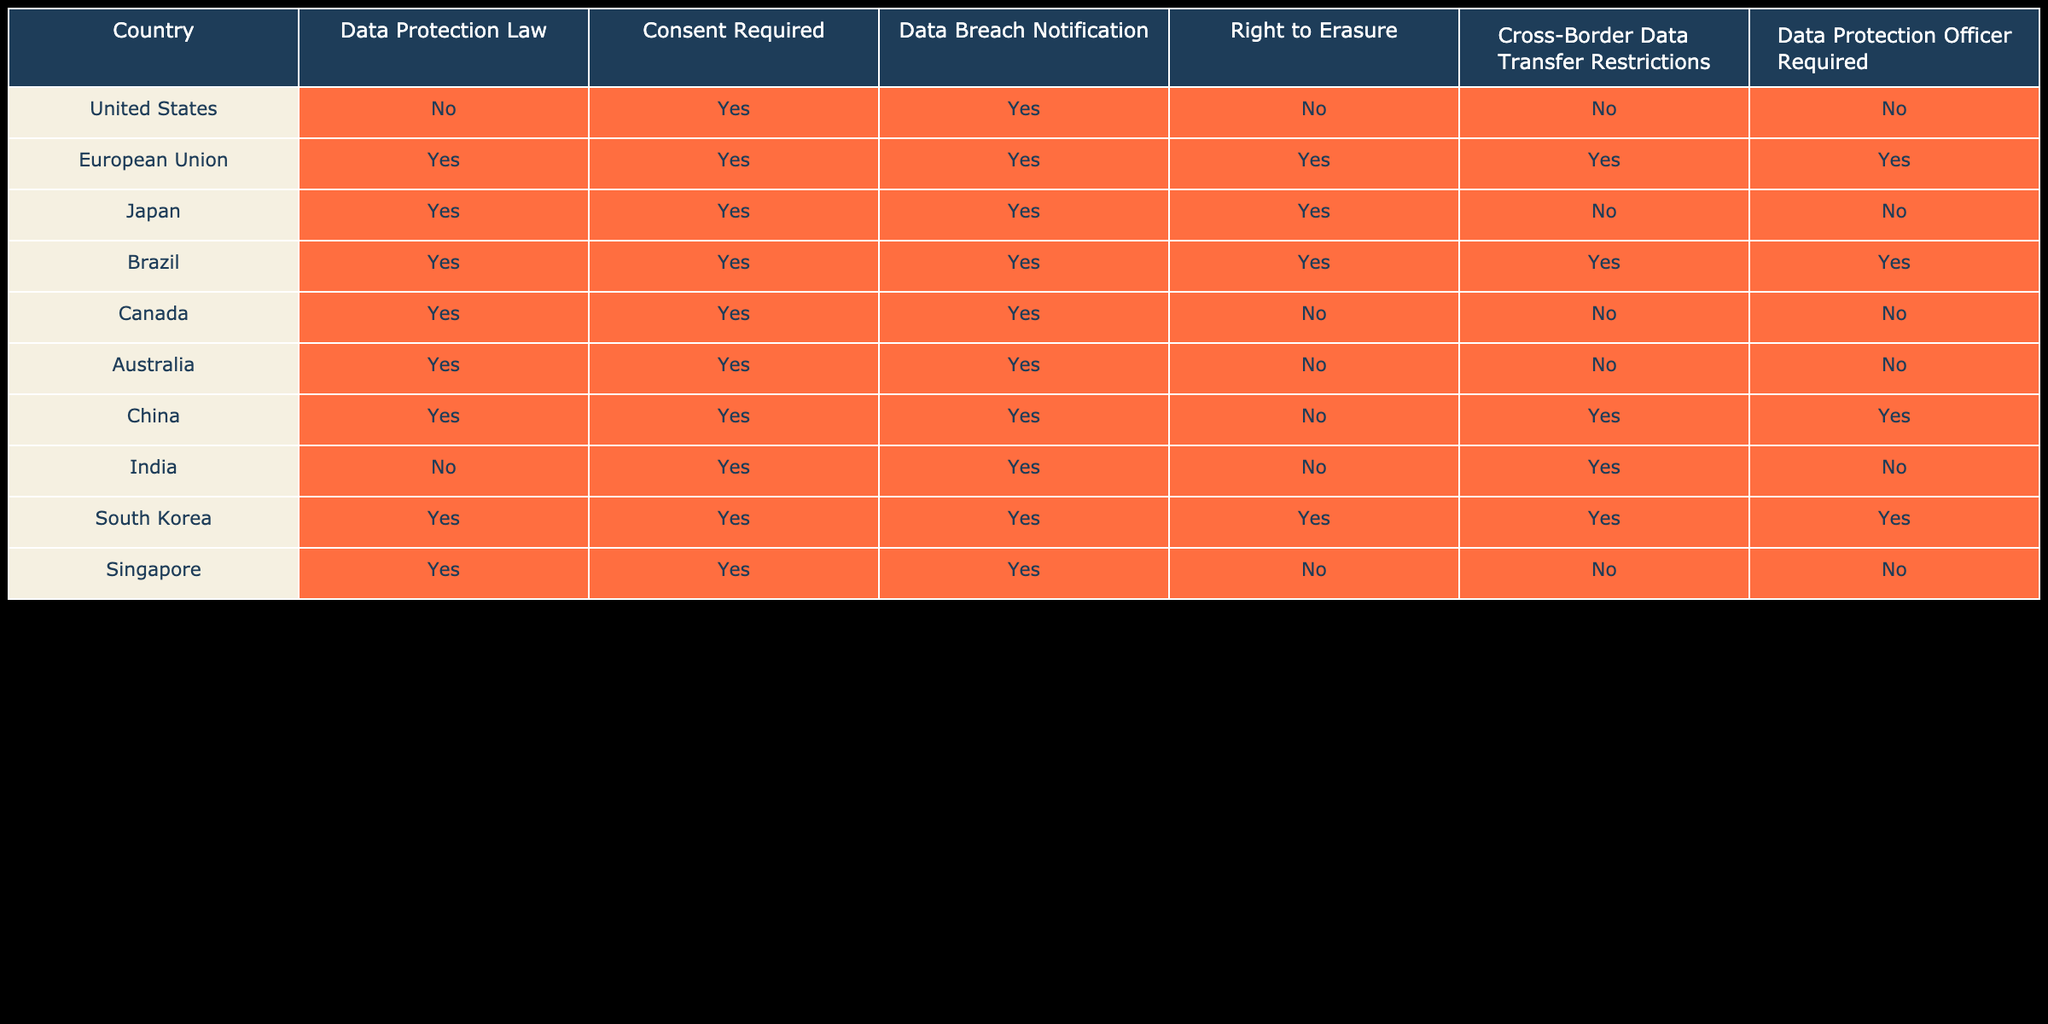Which country requires consent for data protection? By reviewing the "Consent Required" column, I observe that several countries show "Yes." They include the European Union, Japan, Brazil, Canada, Australia, China, India, South Korea, and Singapore.
Answer: European Union, Japan, Brazil, Canada, Australia, China, India, South Korea, Singapore How many countries have a Right to Erasure? To determine the number of countries with a "Right to Erasure," I count the entries marked "Yes" in that column. The countries are the European Union, Japan, Brazil, South Korea, and the United States, totaling five countries.
Answer: 5 Is data breach notification required in Canada? I look at the row for Canada in the "Data Breach Notification" column, which indicates "Yes."
Answer: Yes Which country has cross-border data transfer restrictions but does not require a Data Protection Officer? In the "Cross-Border Data Transfer Restrictions" column, I look for the countries marked "Yes" and then check the corresponding "Data Protection Officer Required" column for "No." China meets this criteria as it has cross-border transfer restrictions but does not require a Data Protection Officer.
Answer: China What is the percentage of countries that require consent for data protection laws? First, I count the total number of countries, which is 10. Then, I count the countries that require consent (nine: European Union, Japan, Brazil, Canada, Australia, China, India, South Korea, Singapore). I calculate the percentage: (9/10)*100 = 90%.
Answer: 90% 